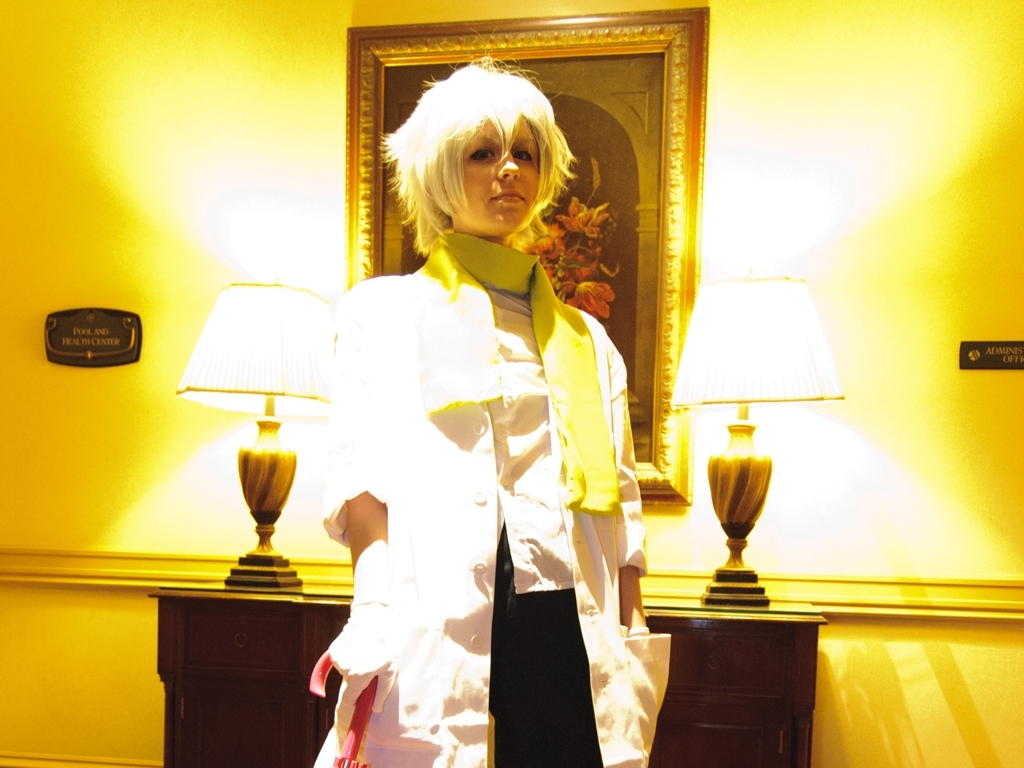Is the image clear? The image is mostly clear with some overexposure in areas due to the bright lighting, which doesn't significantly impact the visibility of the central figure. 